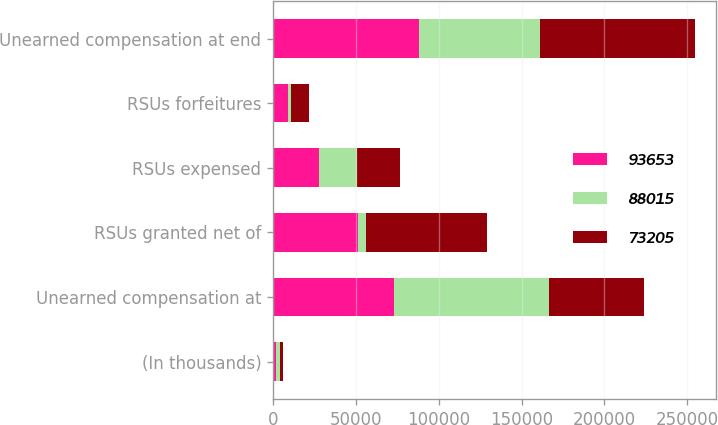Convert chart. <chart><loc_0><loc_0><loc_500><loc_500><stacked_bar_chart><ecel><fcel>(In thousands)<fcel>Unearned compensation at<fcel>RSUs granted net of<fcel>RSUs expensed<fcel>RSUs forfeitures<fcel>Unearned compensation at end<nl><fcel>93653<fcel>2014<fcel>73205<fcel>51575<fcel>27966<fcel>8799<fcel>88015<nl><fcel>88015<fcel>2013<fcel>93653<fcel>4406<fcel>22881<fcel>1973<fcel>73205<nl><fcel>73205<fcel>2012<fcel>57315<fcel>73255<fcel>25728<fcel>11189<fcel>93653<nl></chart> 